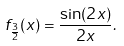Convert formula to latex. <formula><loc_0><loc_0><loc_500><loc_500>f _ { \frac { 3 } { 2 } } ( x ) = { \frac { \sin ( 2 x ) } { 2 x } } .</formula> 